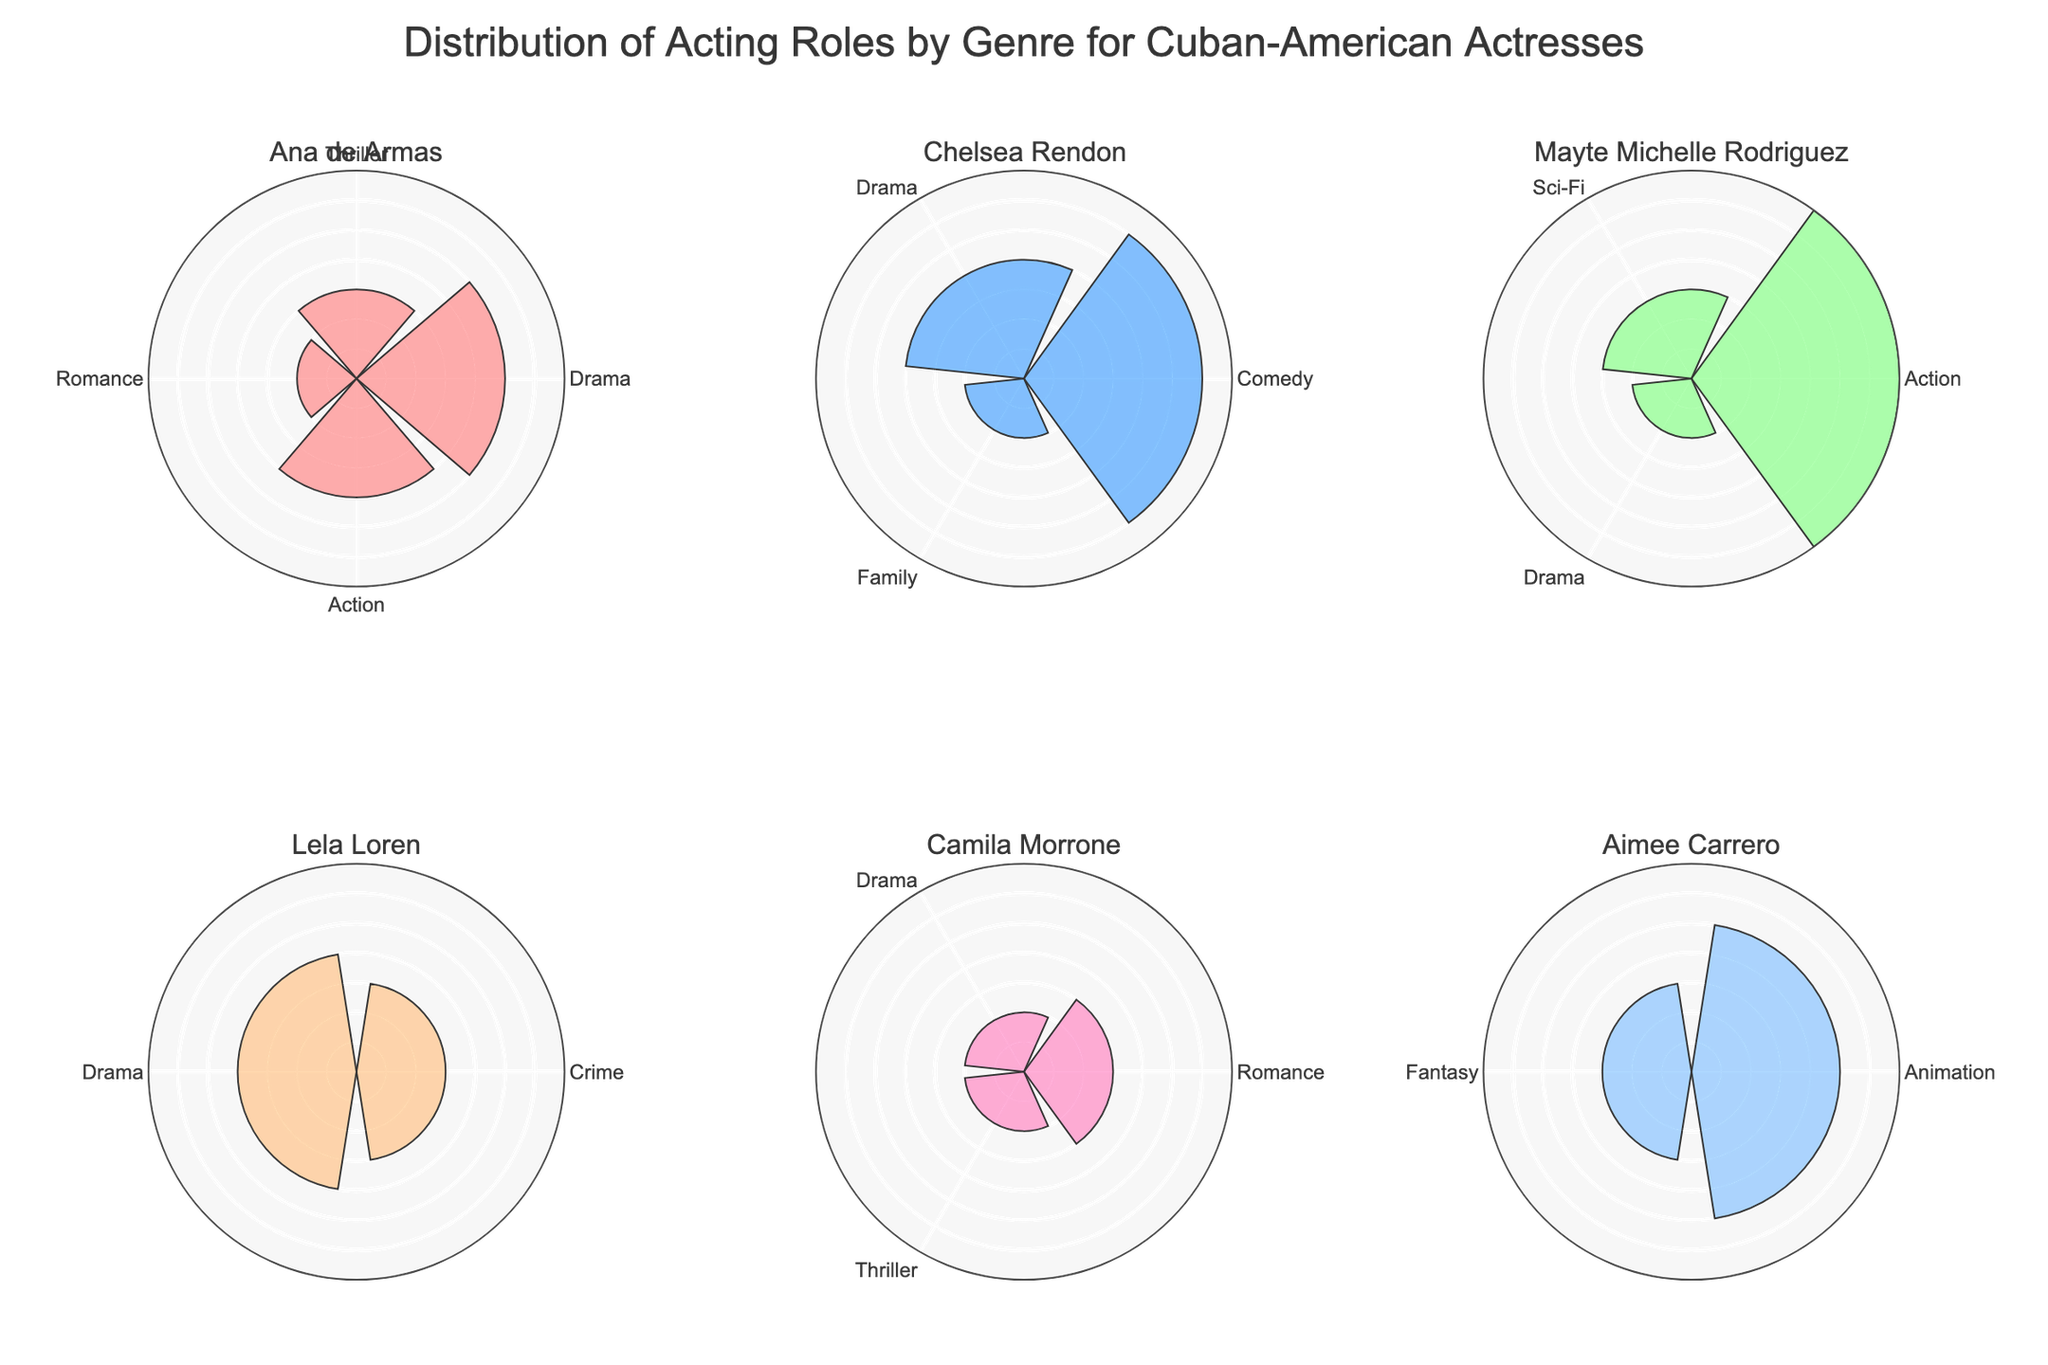Which Cuban-American actress has the most acting roles in Action genre? Look at the subplot for each actress and find the bar representing the Action genre. Identify the actress with the highest value. Mayte Michelle Rodriguez has the highest value in Action.
Answer: Mayte Michelle Rodriguez Which genre has Chelsea Rendon acted in the most? Check Chelsea Rendon's subplot and see which genre's bar extends the furthest. The Comedy genre has the highest value.
Answer: Comedy How many total roles did Ana de Armas have in 2013? Sum the values for all genres in Ana de Armas's subplot for the year 2013. Drama: 5, Thriller: 3. 5 + 3 = 8 roles
Answer: 8 Which genre is least represented among these actresses? Look at the subplots for all actresses and find the genre with the smallest total number of roles across all actresses and years. The Family genre appears only once.
Answer: Family Who has had roles in genres more varied, Lela Loren or Aimee Carrero? Count the number of distinct genres in the subplots for Lela Loren and Aimee Carrero. Lela Loren has roles in three genres: Drama, Crime, and Romance. Aimee Carrero has roles in two genres: Animation and Fantasy.
Answer: Lela Loren Compare the number of Drama roles between Lela Loren and Camila Morrone. Who has more? Look at the Drama genre bars in Lela Loren's and Camila Morrone's subplots and compare their heights to see who has a higher count. Lela Loren has 4 Drama roles, while Camila Morrone has 2.
Answer: Lela Loren What is the total number of roles across all genres for Mayte Michelle Rodriguez? Sum the values for all genres in Mayte Michelle Rodriguez's subplot: Action: 7, Sci-Fi: 3, Drama: 2. 7 + 3 + 2 = 12 roles
Answer: 12 In which year did Aimee Carrero have the highest number of roles? Check the counts of roles in each genre for Aimee Carrero's subplot and identify the year with the highest total. Animation: 5 in 2021, Fantasy: 3 in 2022. 2021 has the highest total.
Answer: 2021 